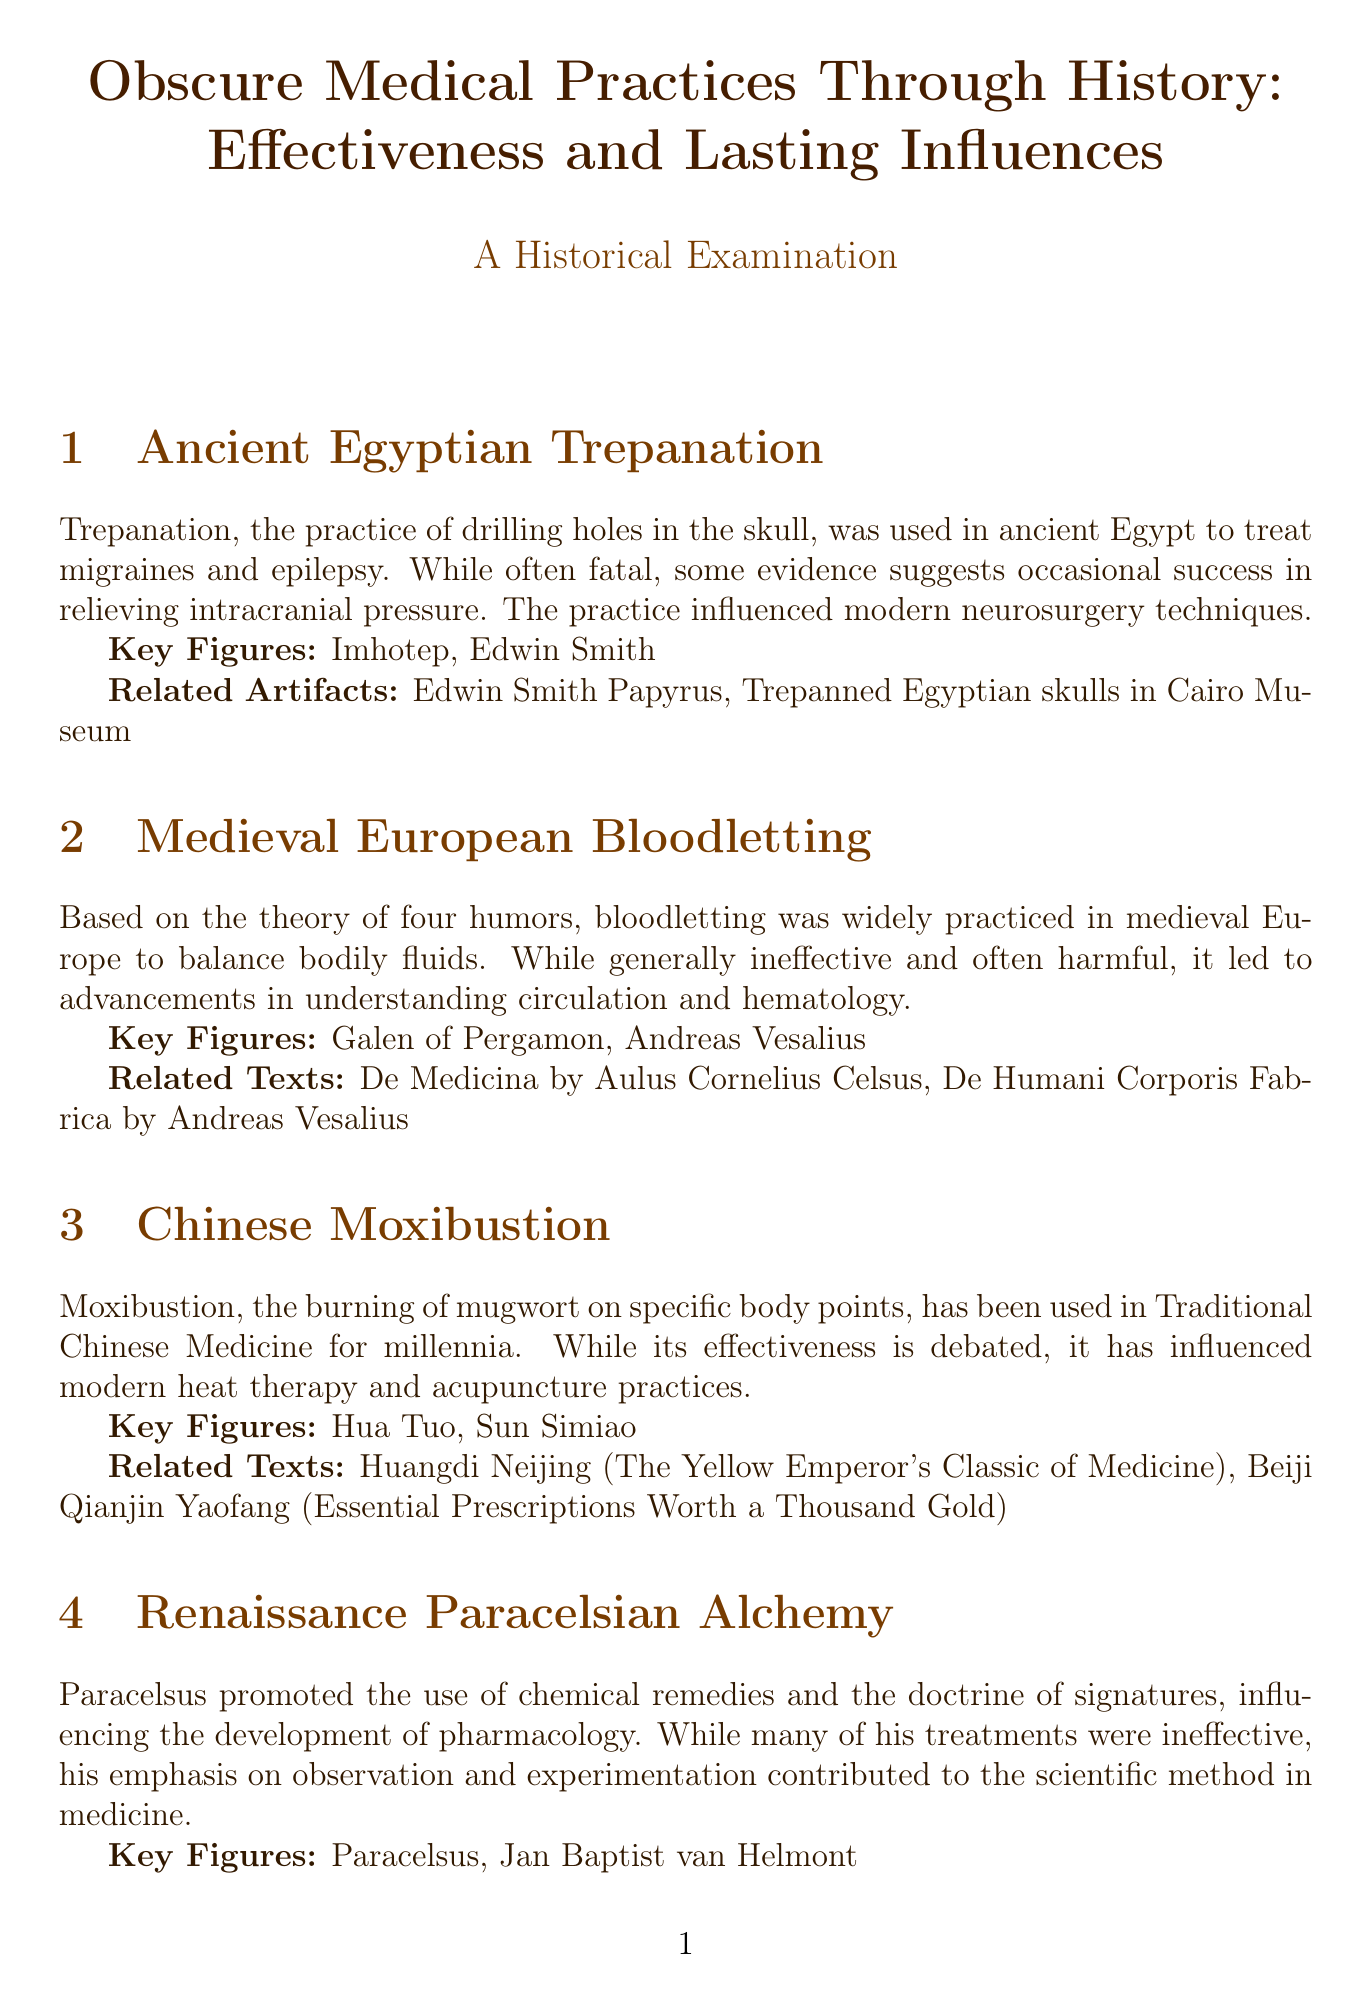What practice was used in ancient Egypt to treat migraines? The document states that trepanation was used to treat migraines and epilepsy in ancient Egypt.
Answer: Trepanation Who were the key figures associated with medieval European bloodletting? The section on medieval European bloodletting lists Galen of Pergamon and Andreas Vesalius as key figures.
Answer: Galen of Pergamon, Andreas Vesalius What theory was central to the practice of bloodletting? The document mentions that bloodletting was based on the theory of four humors.
Answer: Four humors Which practice is described as influencing modern heat therapy? The text specifies that moxibustion has influenced modern heat therapy and acupuncture practices.
Answer: Moxibustion Who promoted the doctrine of signatures? The section on Paracelsian Alchemy states that Paracelsus promoted the doctrine of signatures.
Answer: Paracelsus What was the main result of Franz Mesmer's work? The document indicates that Mesmer's work led to increased interest in the power of suggestion and hypnosis in medicine.
Answer: Power of suggestion and hypnosis What harmful effect is associated with prefrontal lobotomy? The document describes prefrontal lobotomy as having harmful effects despite its widespread use.
Answer: Harmful effects What does the conclusion highlight as a lasting influence on medical practices? The conclusion lists the development of evidence-based medicine as one of the lasting influences from these practices.
Answer: Development of evidence-based medicine 